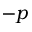<formula> <loc_0><loc_0><loc_500><loc_500>- p</formula> 